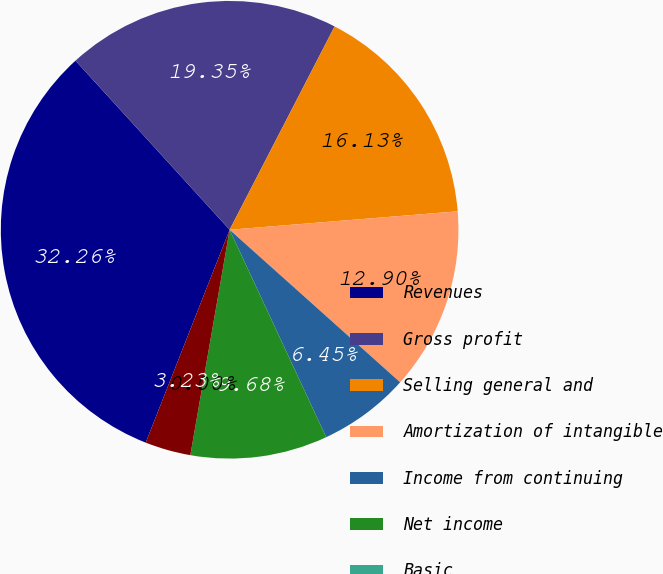Convert chart. <chart><loc_0><loc_0><loc_500><loc_500><pie_chart><fcel>Revenues<fcel>Gross profit<fcel>Selling general and<fcel>Amortization of intangible<fcel>Income from continuing<fcel>Net income<fcel>Basic<fcel>Fully diluted<nl><fcel>32.26%<fcel>19.35%<fcel>16.13%<fcel>12.9%<fcel>6.45%<fcel>9.68%<fcel>0.0%<fcel>3.23%<nl></chart> 